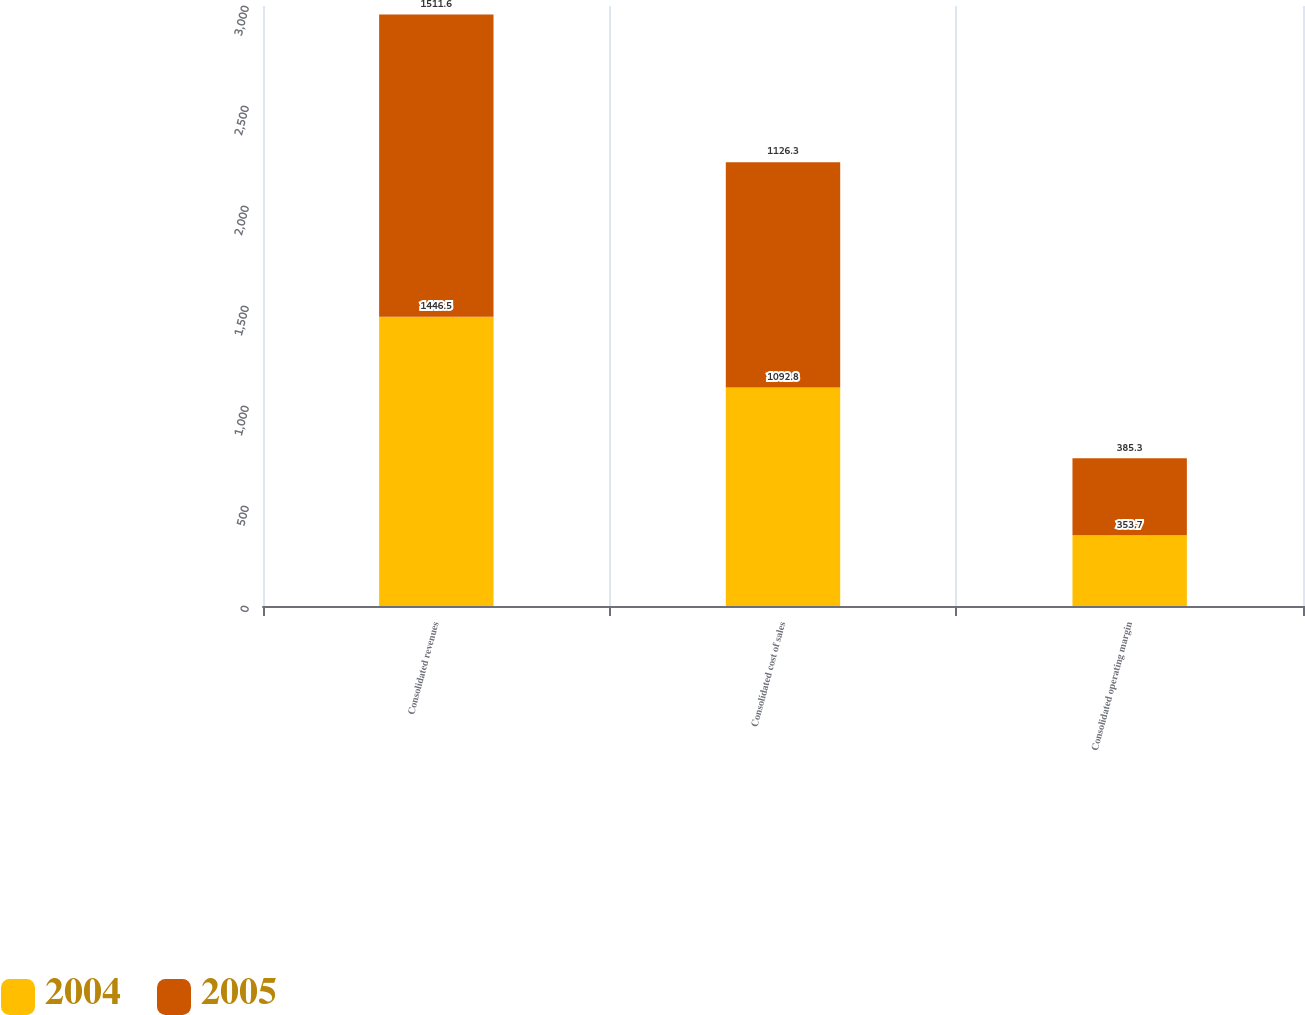Convert chart to OTSL. <chart><loc_0><loc_0><loc_500><loc_500><stacked_bar_chart><ecel><fcel>Consolidated revenues<fcel>Consolidated cost of sales<fcel>Consolidated operating margin<nl><fcel>2004<fcel>1446.5<fcel>1092.8<fcel>353.7<nl><fcel>2005<fcel>1511.6<fcel>1126.3<fcel>385.3<nl></chart> 